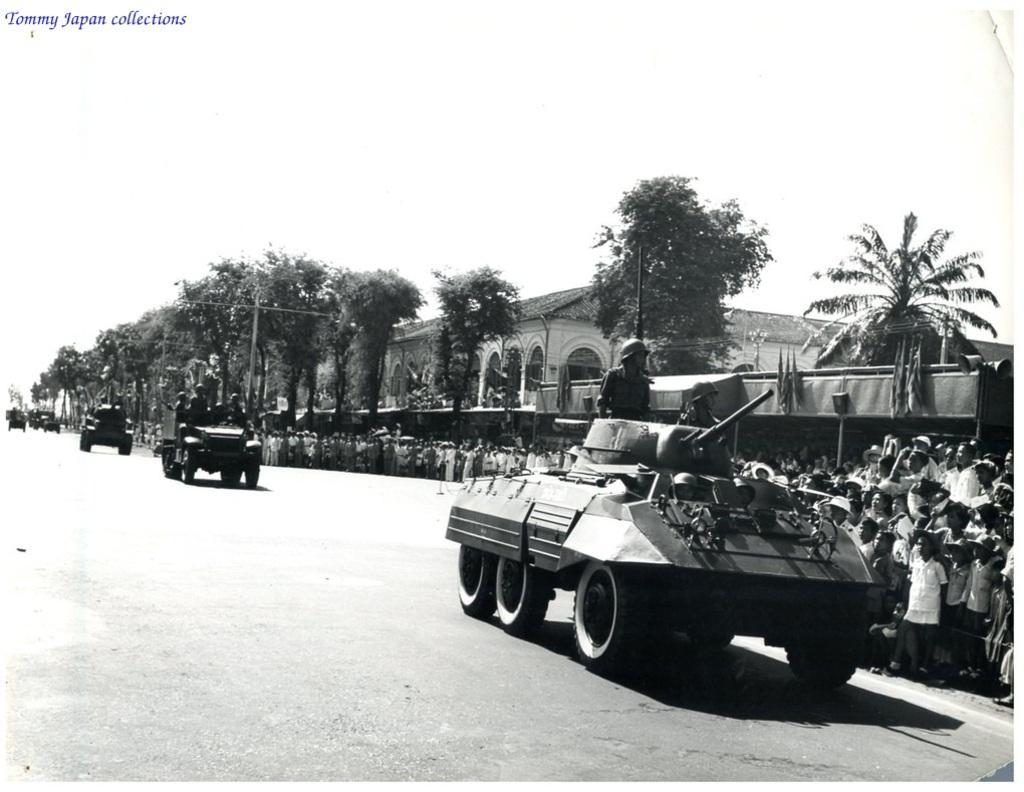In one or two sentences, can you explain what this image depicts? This is a black and white image. In the center of the image we can see some persons are sitting in the vehicles. In the background of the image we can see a group of people are standing and also we can see trees, building, shed. At the bottom of the image we can see the road. At the top of the image we can see the sky. 